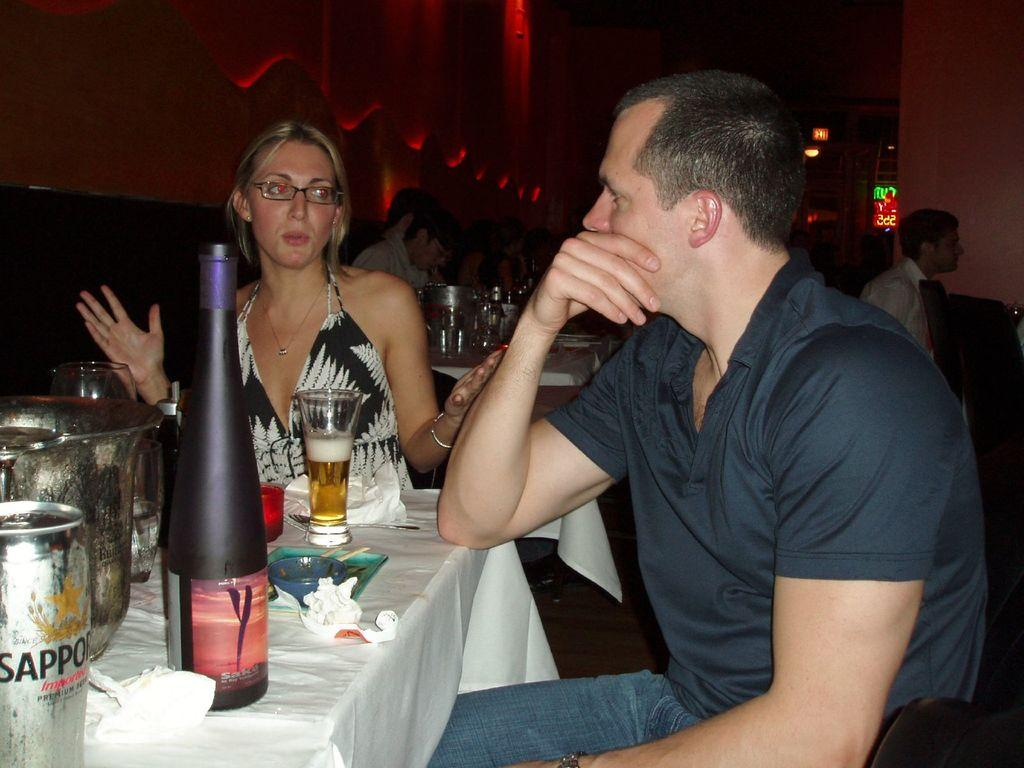<image>
Provide a brief description of the given image. A couple are drinking Sapporo beer at a restaurant. 